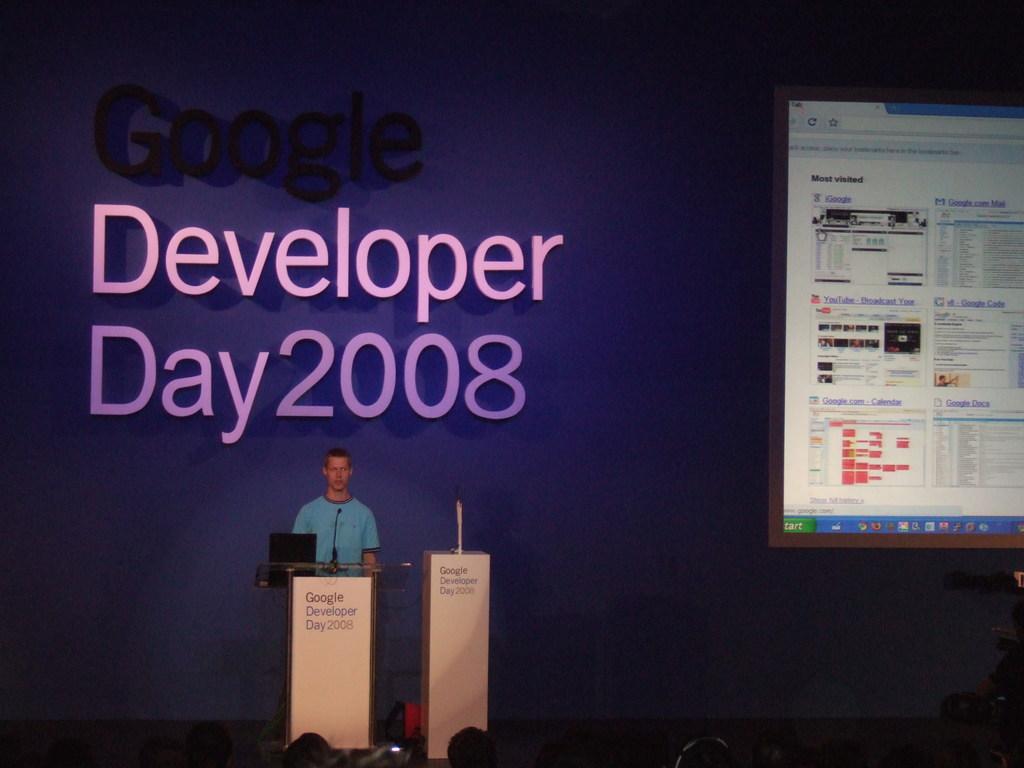What year was this?
Offer a terse response. 2008. What is typed above day?
Your response must be concise. Developer. 